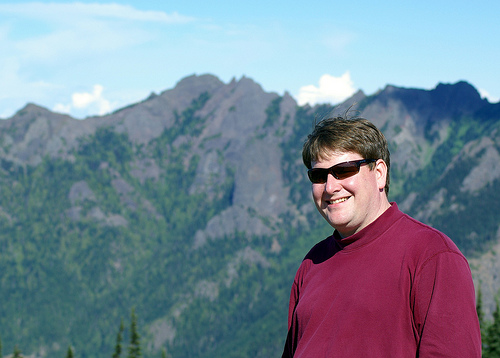<image>
Is the man next to the mountain? Yes. The man is positioned adjacent to the mountain, located nearby in the same general area. Is there a head in front of the mountain? Yes. The head is positioned in front of the mountain, appearing closer to the camera viewpoint. 